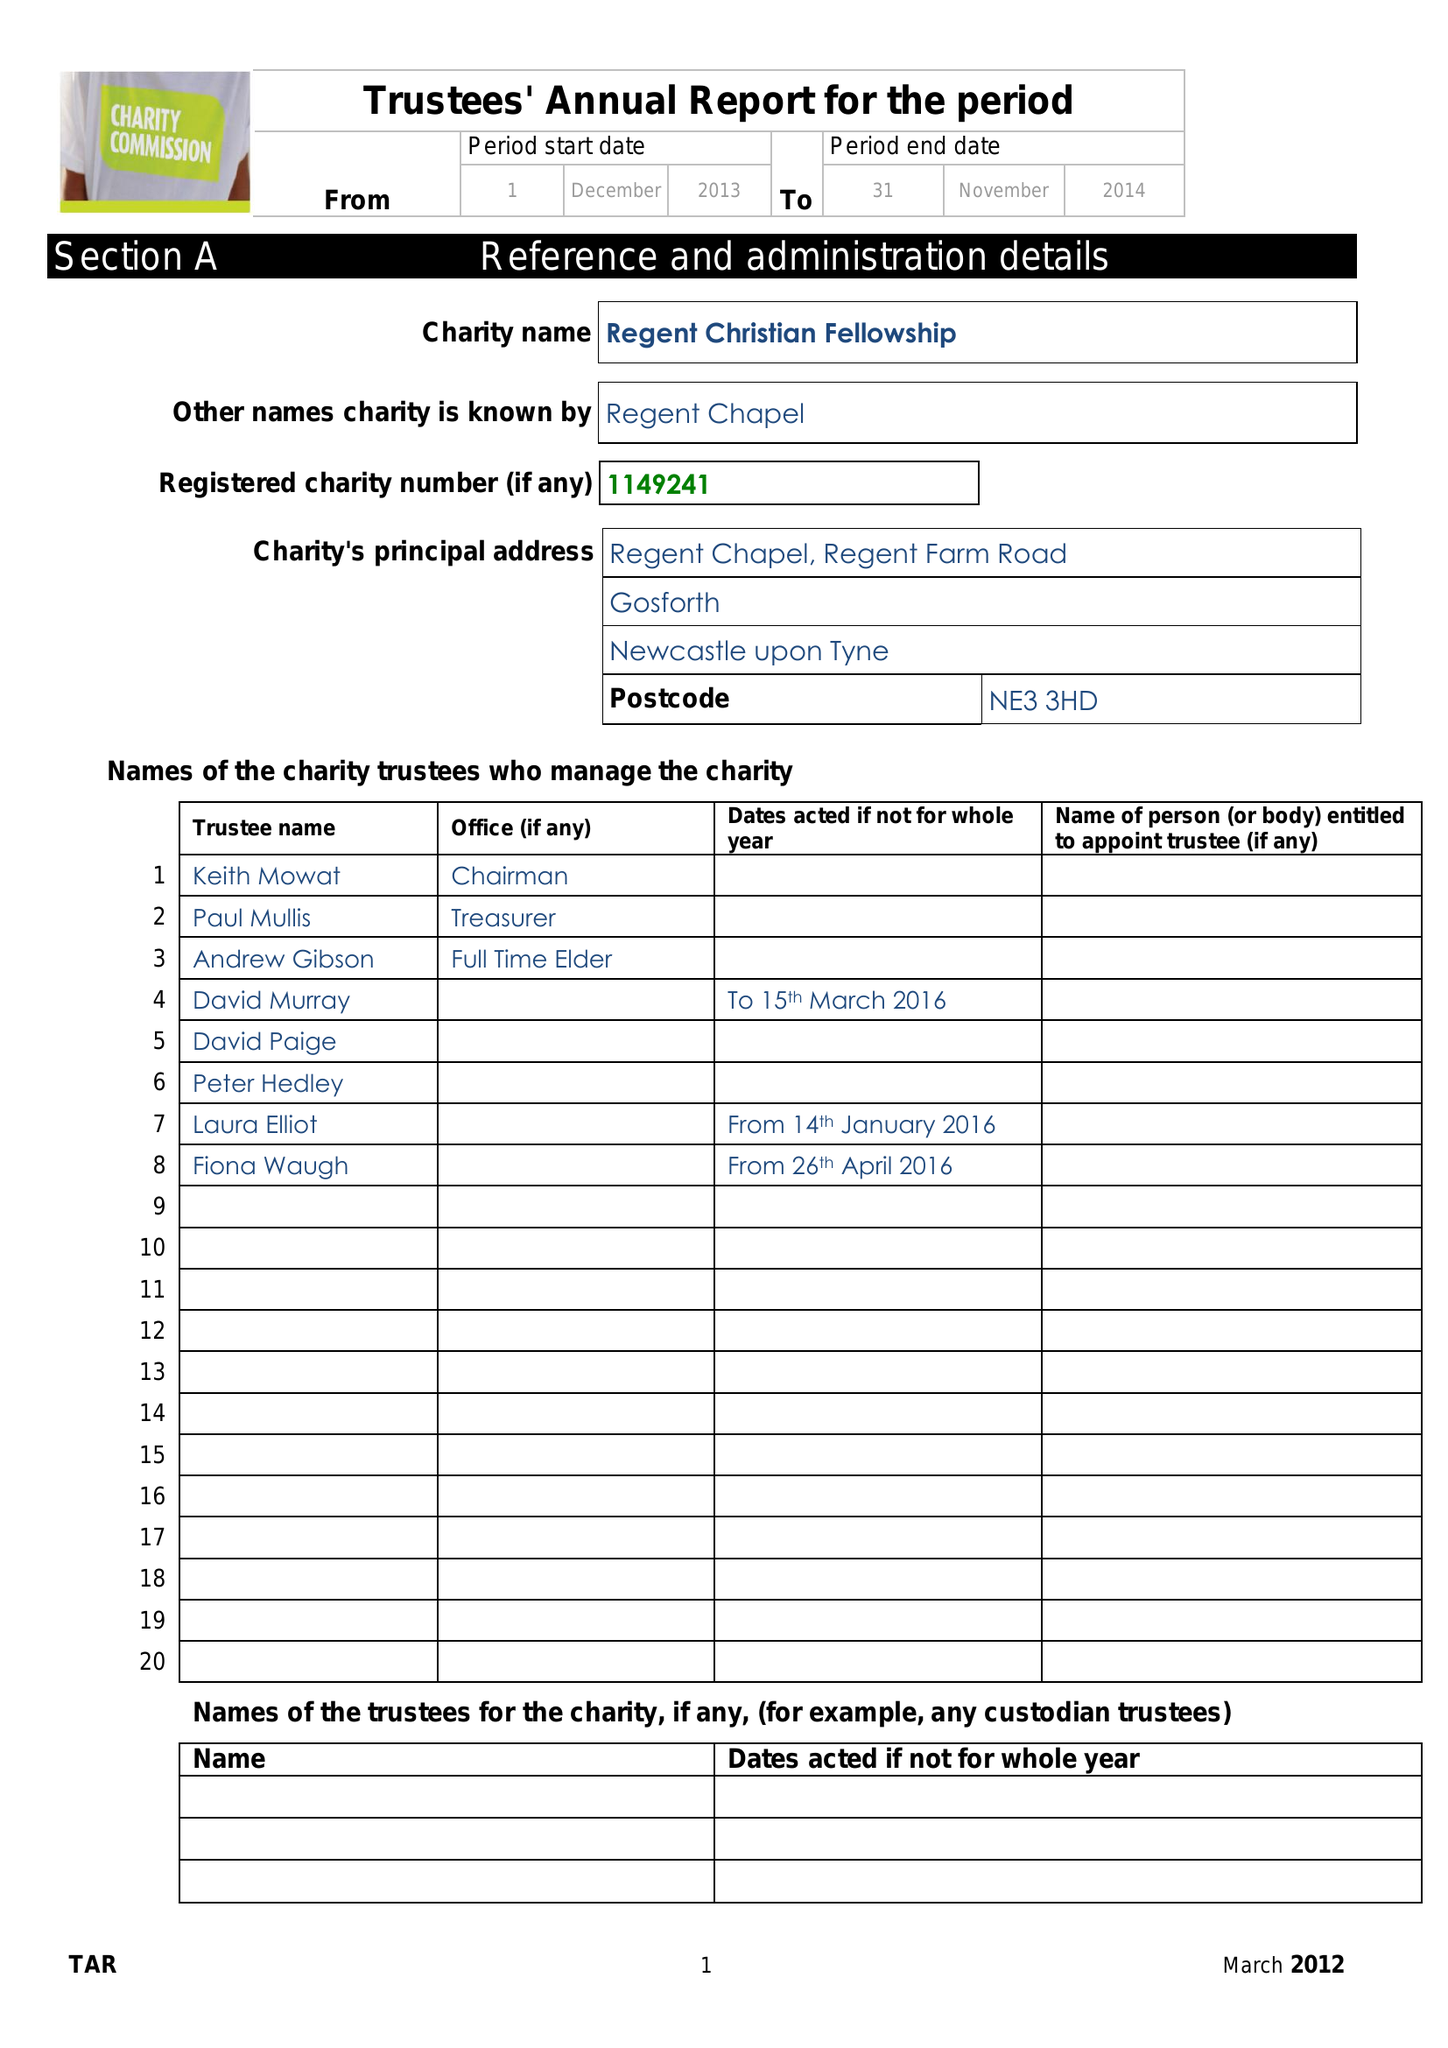What is the value for the charity_name?
Answer the question using a single word or phrase. Regent Christian Fellowship 